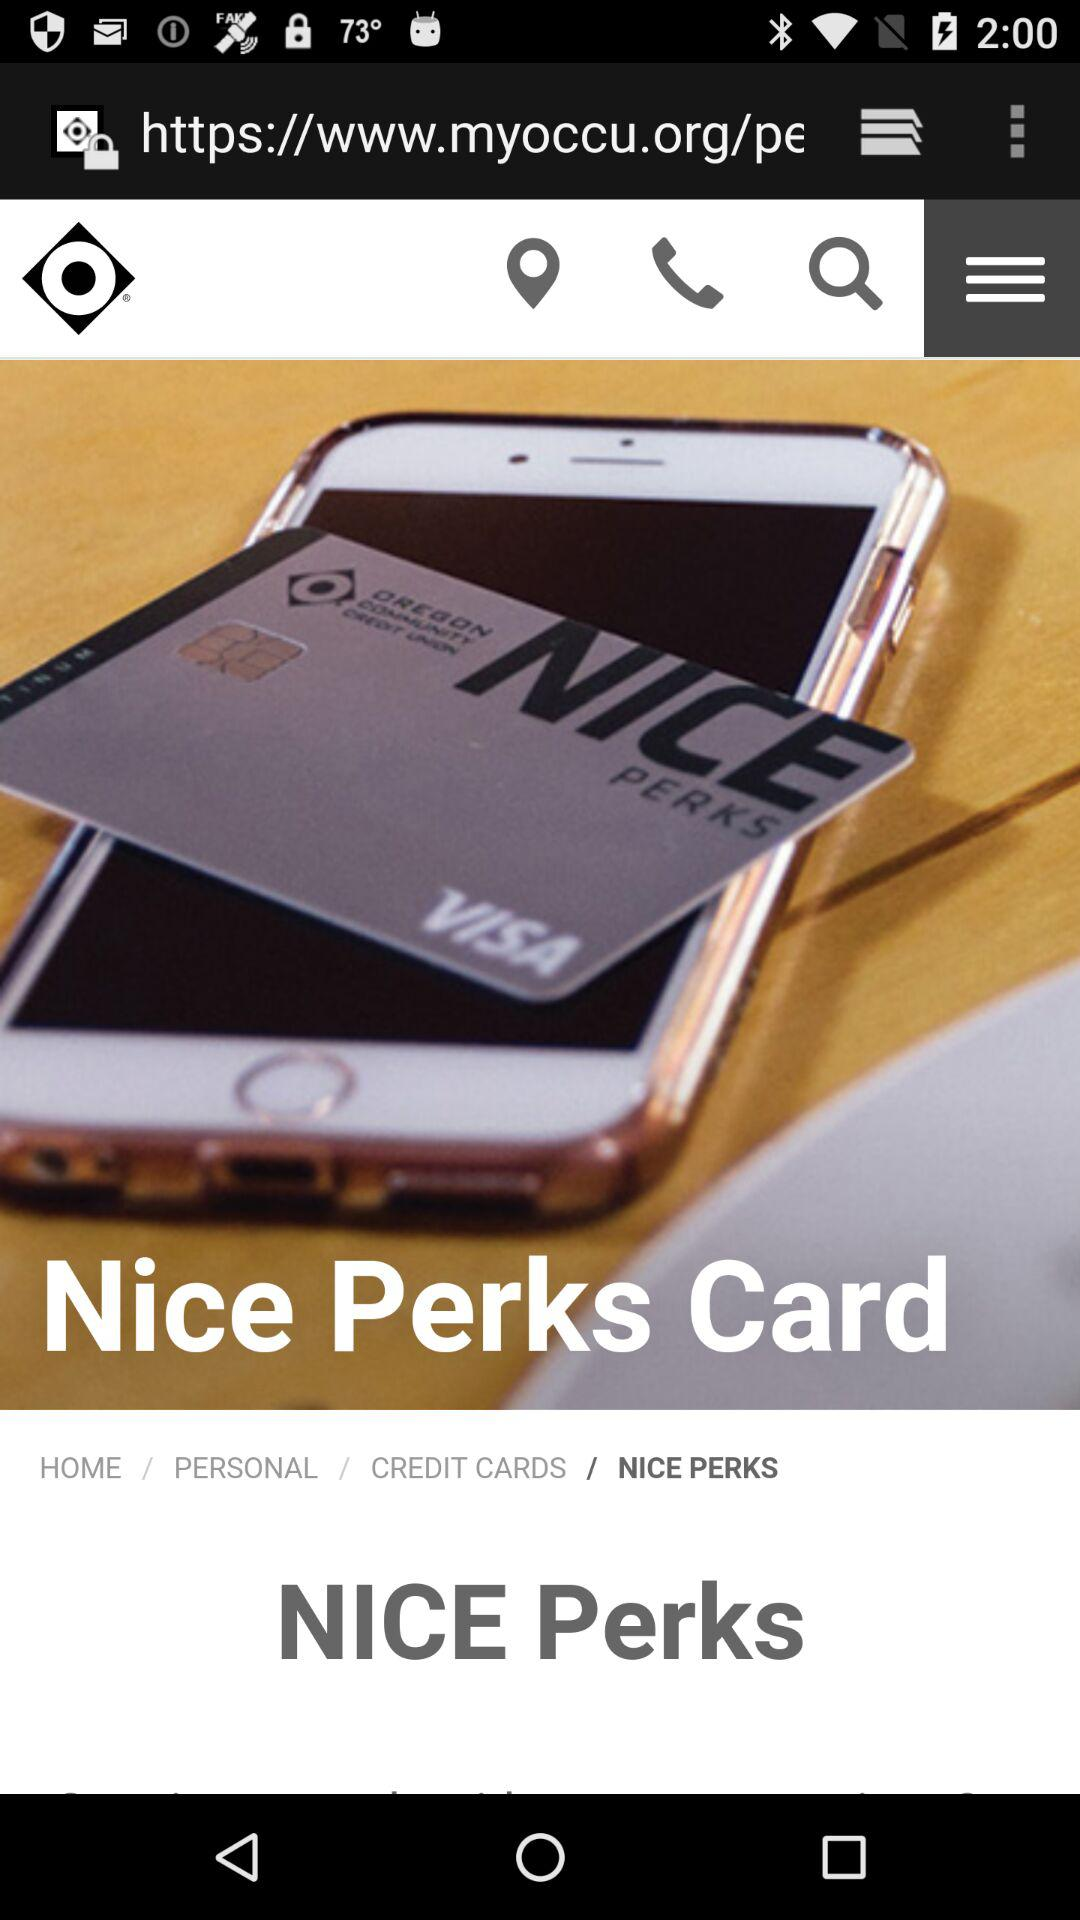How many surahs are there on the app?
Answer the question using a single word or phrase. 21 